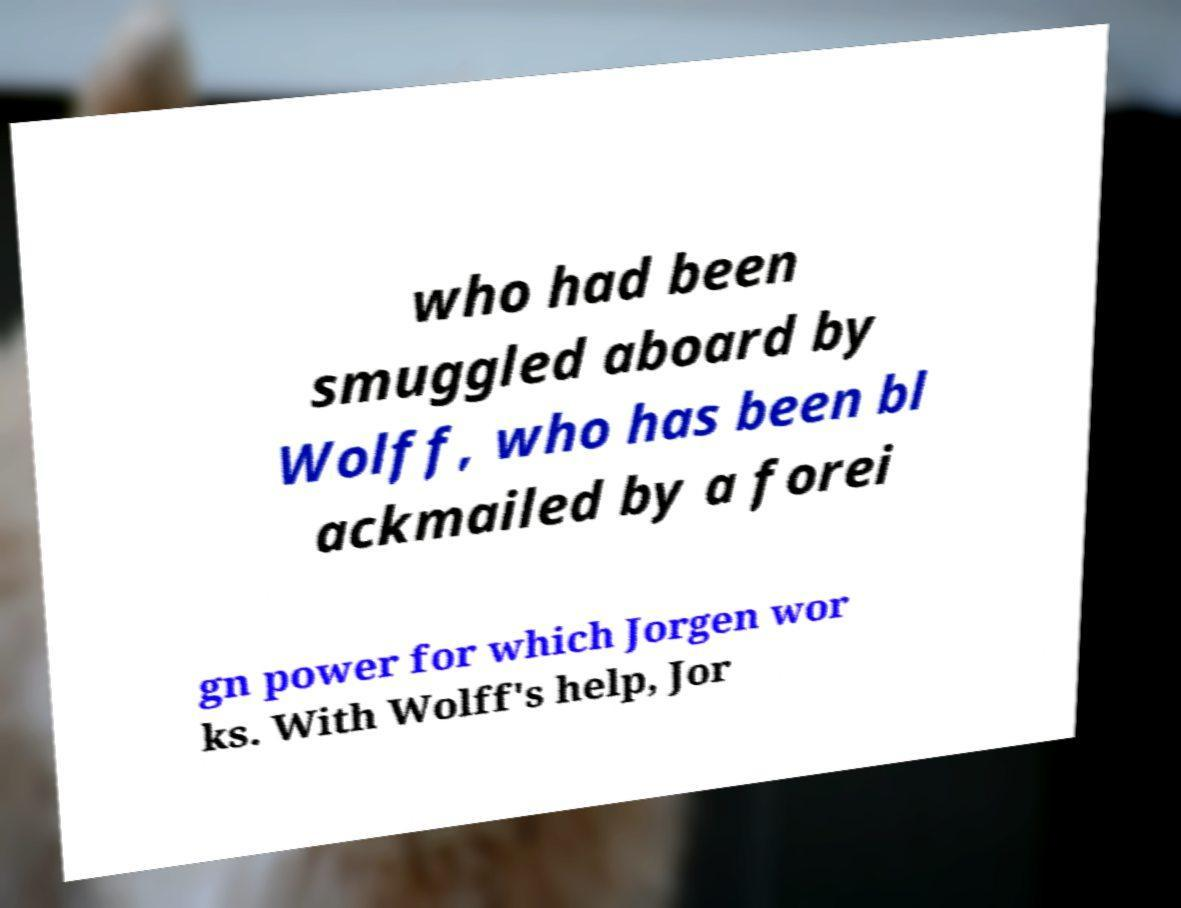Could you extract and type out the text from this image? who had been smuggled aboard by Wolff, who has been bl ackmailed by a forei gn power for which Jorgen wor ks. With Wolff's help, Jor 